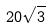<formula> <loc_0><loc_0><loc_500><loc_500>2 0 \sqrt { 3 }</formula> 